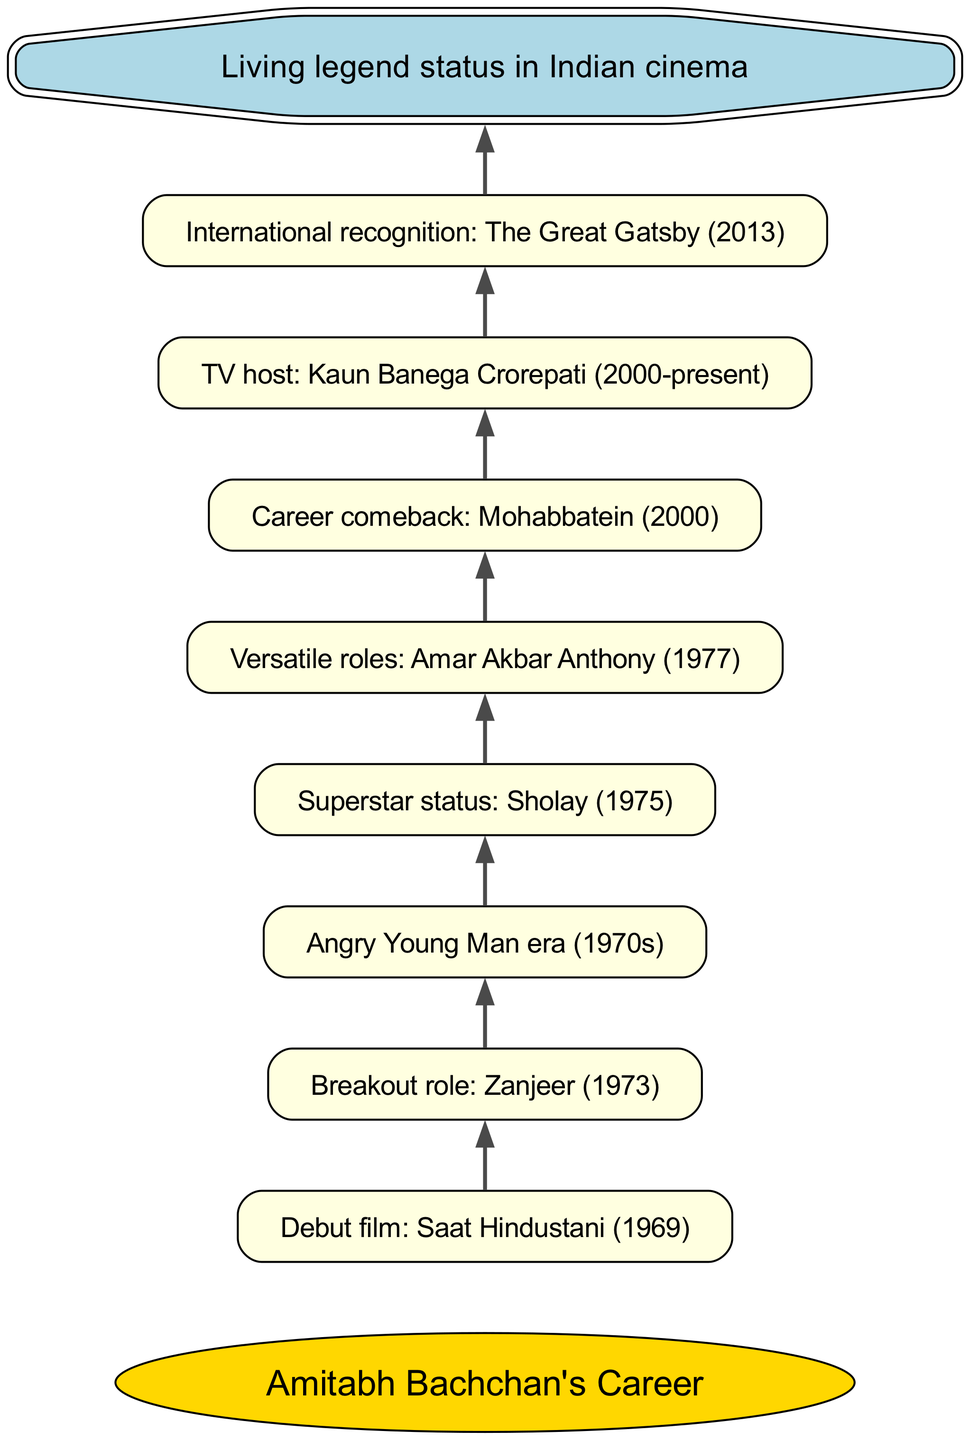What was Amitabh Bachchan's debut film? The diagram shows that Amitabh Bachchan's career began with his debut film "Saat Hindustani" in 1969. This information is directly indicated in the flow chart.
Answer: Saat Hindustani (1969) Which film marked Amitabh Bachchan's breakout role? According to the flow chart, the breakout role for Amitabh Bachchan is indicated as "Zanjeer" in 1973, which follows directly after his debut film.
Answer: Zanjeer (1973) What significant era began in the 1970s for Amitabh Bachchan? The diagram highlights the "Angry Young Man era" (1970s) as a significant phase in Amitabh Bachchan's career, which follows after his breakout role.
Answer: Angry Young Man era (1970s) Which film established Amitabh Bachchan as a superstar? The flow chart indicates that "Sholay" (1975) is the film that elevated Amitabh Bachchan to superstar status, which is directly linked after the Angry Young Man era.
Answer: Sholay (1975) What type of roles did Amitabh Bachchan diversify into after becoming a superstar? The diagram states that after establishing his superstar status, he took on "Versatile roles" with the film "Amar Akbar Anthony" (1977) shown in the chart.
Answer: Versatile roles: Amar Akbar Anthony (1977) What event is marked as Amitabh Bachchan's career comeback? The chart shows that his career comeback is noted as "Mohabbatein" (2000), which follows the period of versatile roles, indicating a resurgence in his career.
Answer: Mohabbatein (2000) For how long has Amitabh Bachchan been a TV host? The diagram indicates that Amitabh Bachchan has hosted "Kaun Banega Crorepati" since 2000 and continues to do so, showing a span from 2000 to the present.
Answer: 2000-present Which international film contributed to Amitabh Bachchan's global recognition? The flow chart notes "The Great Gatsby" (2013) as the film that marked Amitabh Bachchan's international recognition, following his years as a TV host.
Answer: The Great Gatsby (2013) What does the diagram signify about Amitabh Bachchan's status in Indian cinema? The final node in the chart states that he has attained "Living legend status in Indian cinema," which is a summary of his entire career progression outlined in the diagram.
Answer: Living legend status in Indian cinema 